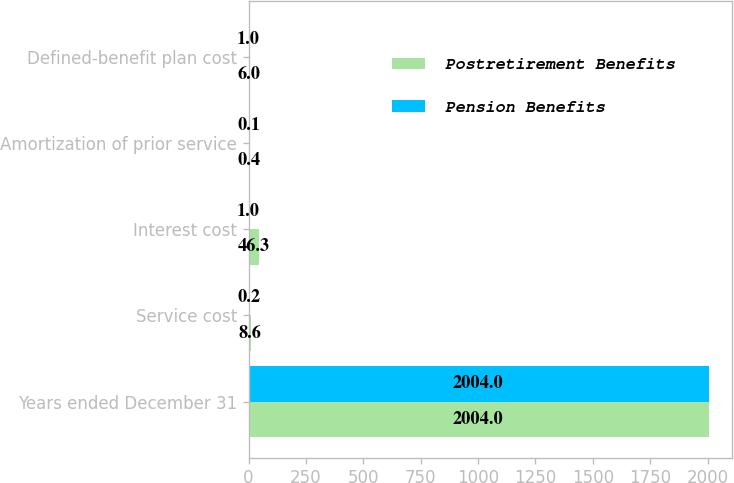Convert chart to OTSL. <chart><loc_0><loc_0><loc_500><loc_500><stacked_bar_chart><ecel><fcel>Years ended December 31<fcel>Service cost<fcel>Interest cost<fcel>Amortization of prior service<fcel>Defined-benefit plan cost<nl><fcel>Postretirement Benefits<fcel>2004<fcel>8.6<fcel>46.3<fcel>0.4<fcel>6<nl><fcel>Pension Benefits<fcel>2004<fcel>0.2<fcel>1<fcel>0.1<fcel>1<nl></chart> 